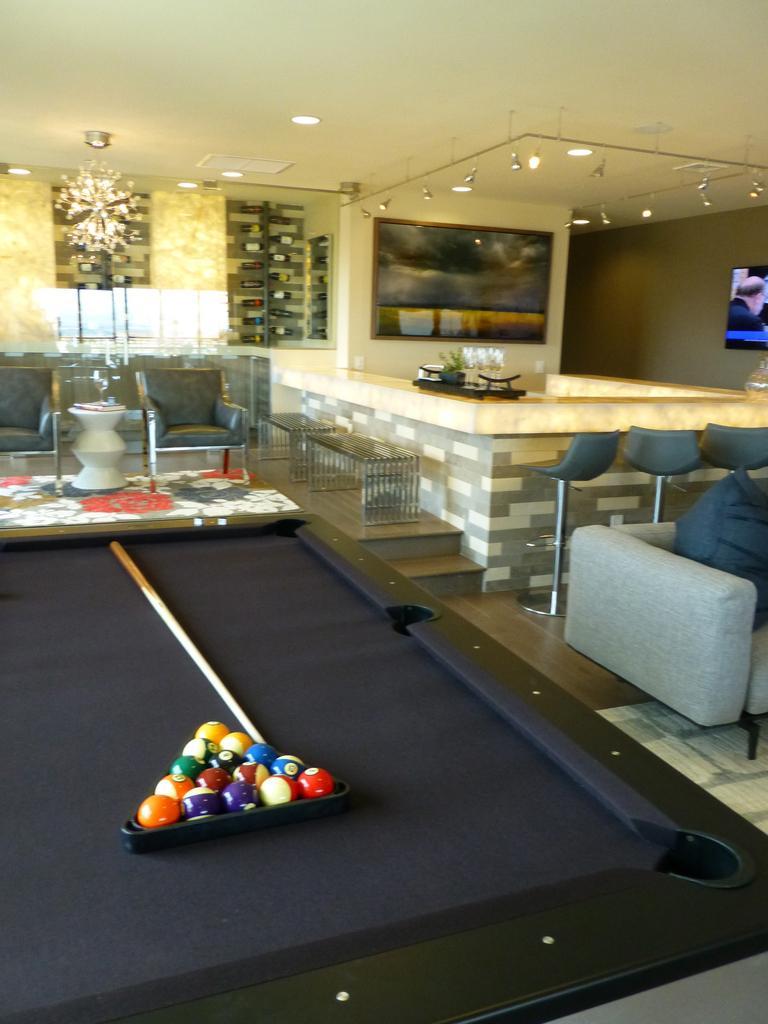Please provide a concise description of this image. The image is taken in the room. At the left there is a billiard board. On the right there is a sofa behind it there is a counter table we can also see some stools. In the background there is a wall. At the top there are lights. 